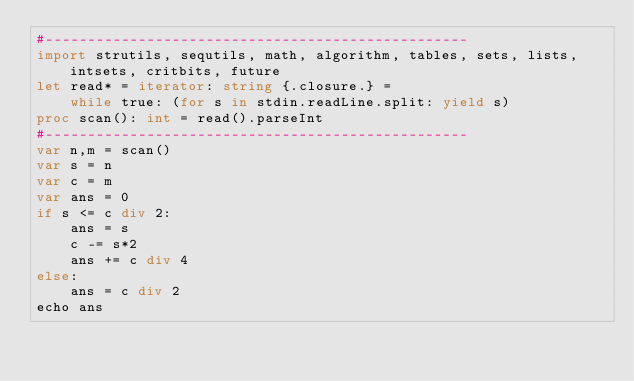<code> <loc_0><loc_0><loc_500><loc_500><_Nim_>#--------------------------------------------------
import strutils, sequtils, math, algorithm, tables, sets, lists, intsets, critbits, future
let read* = iterator: string {.closure.} =
    while true: (for s in stdin.readLine.split: yield s)
proc scan(): int = read().parseInt
#--------------------------------------------------
var n,m = scan()
var s = n
var c = m
var ans = 0
if s <= c div 2:
    ans = s
    c -= s*2
    ans += c div 4
else:
    ans = c div 2
echo ans</code> 